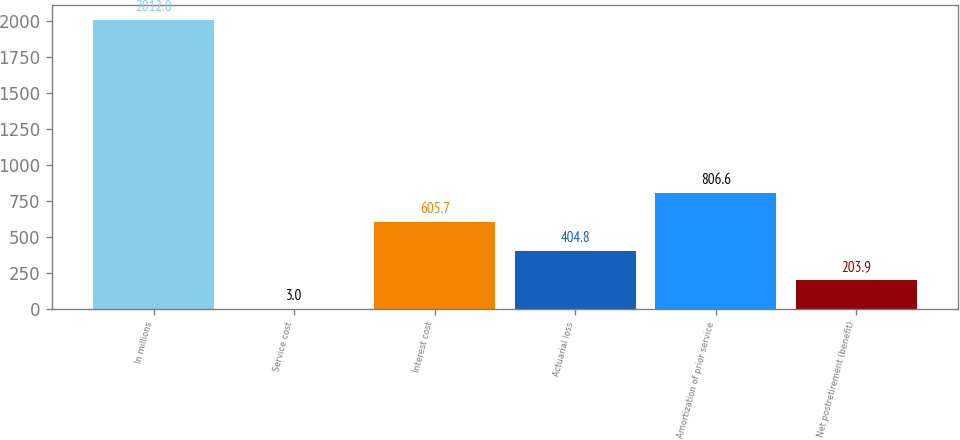<chart> <loc_0><loc_0><loc_500><loc_500><bar_chart><fcel>In millions<fcel>Service cost<fcel>Interest cost<fcel>Actuarial loss<fcel>Amortization of prior service<fcel>Net postretirement (benefit)<nl><fcel>2012<fcel>3<fcel>605.7<fcel>404.8<fcel>806.6<fcel>203.9<nl></chart> 